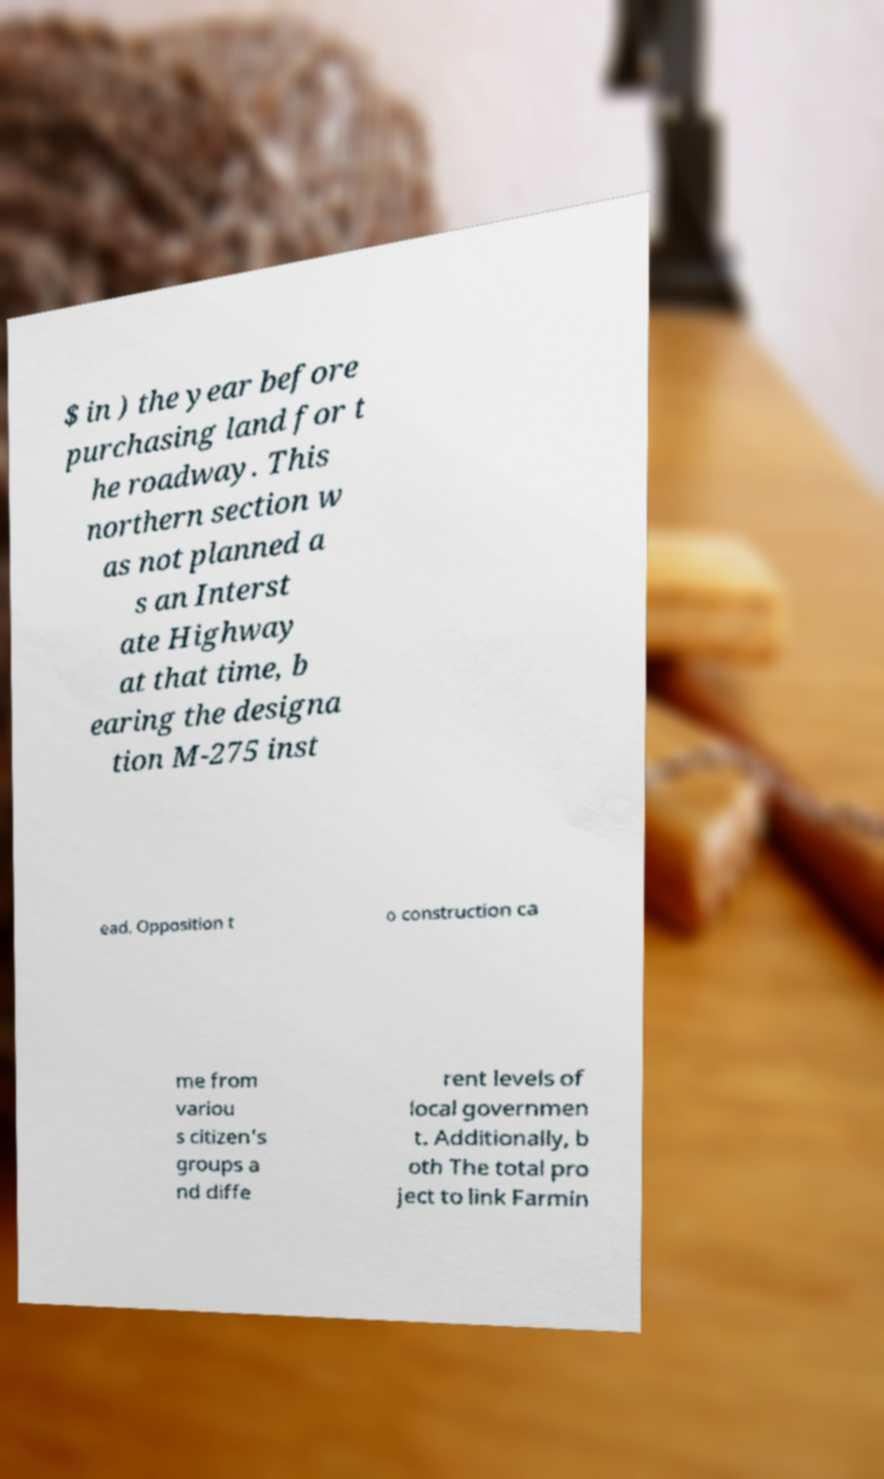I need the written content from this picture converted into text. Can you do that? $ in ) the year before purchasing land for t he roadway. This northern section w as not planned a s an Interst ate Highway at that time, b earing the designa tion M-275 inst ead. Opposition t o construction ca me from variou s citizen's groups a nd diffe rent levels of local governmen t. Additionally, b oth The total pro ject to link Farmin 